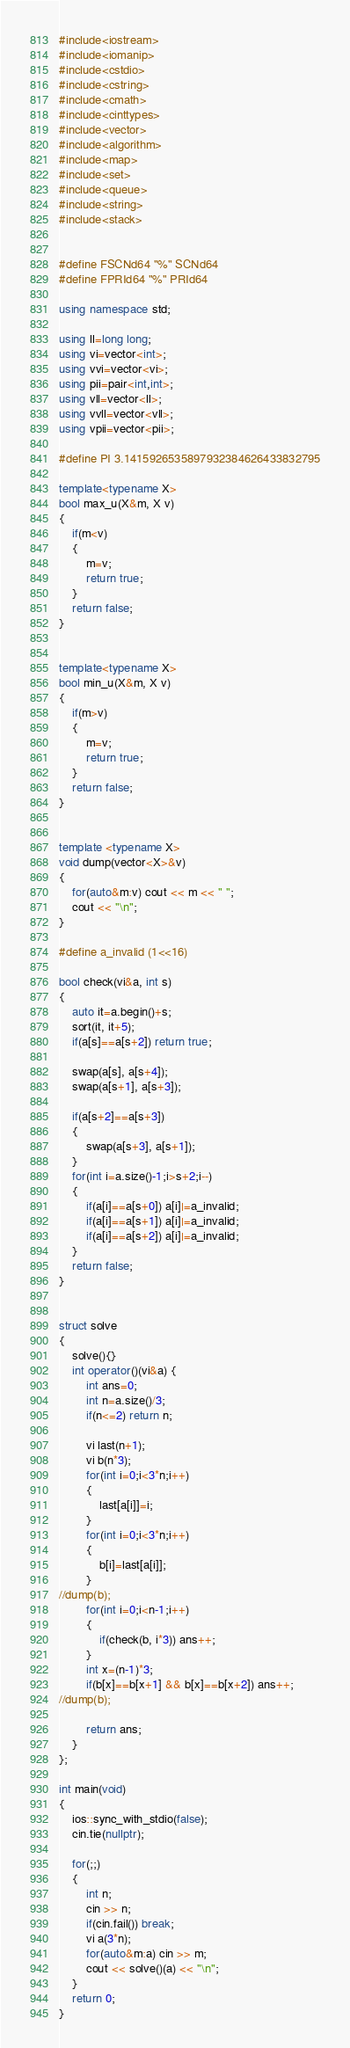<code> <loc_0><loc_0><loc_500><loc_500><_C++_>#include<iostream>
#include<iomanip>
#include<cstdio>
#include<cstring>
#include<cmath>
#include<cinttypes>
#include<vector>
#include<algorithm>
#include<map>
#include<set>
#include<queue>
#include<string>
#include<stack>


#define FSCNd64 "%" SCNd64
#define FPRId64 "%" PRId64

using namespace std;

using ll=long long;
using vi=vector<int>;
using vvi=vector<vi>;
using pii=pair<int,int>;
using vll=vector<ll>;
using vvll=vector<vll>;
using vpii=vector<pii>;

#define PI 3.1415926535897932384626433832795

template<typename X>
bool max_u(X&m, X v)
{
	if(m<v)
	{
		m=v;
		return true;
	}
	return false;
}


template<typename X>
bool min_u(X&m, X v)
{
	if(m>v)
	{
		m=v;
		return true;
	}
	return false;
}


template <typename X>
void dump(vector<X>&v)
{
	for(auto&m:v) cout << m << " ";
	cout << "\n";
}

#define a_invalid (1<<16)

bool check(vi&a, int s)
{
	auto it=a.begin()+s;
	sort(it, it+5);
	if(a[s]==a[s+2]) return true;

	swap(a[s], a[s+4]);
	swap(a[s+1], a[s+3]);

	if(a[s+2]==a[s+3])
	{
		swap(a[s+3], a[s+1]);
	}
	for(int i=a.size()-1;i>s+2;i--)
	{
		if(a[i]==a[s+0]) a[i]|=a_invalid;
		if(a[i]==a[s+1]) a[i]|=a_invalid;
		if(a[i]==a[s+2]) a[i]|=a_invalid;
	}
	return false;
}


struct solve
{
	solve(){}
	int operator()(vi&a) {
		int ans=0;
		int n=a.size()/3;
		if(n<=2) return n;

		vi last(n+1);
		vi b(n*3);
		for(int i=0;i<3*n;i++)
		{
			last[a[i]]=i;
		}
		for(int i=0;i<3*n;i++)
		{
			b[i]=last[a[i]];
		}
//dump(b);
		for(int i=0;i<n-1;i++)
		{
			if(check(b, i*3)) ans++;
		}
		int x=(n-1)*3;
		if(b[x]==b[x+1] && b[x]==b[x+2]) ans++;
//dump(b);

		return ans;
	}
};

int main(void)
{
	ios::sync_with_stdio(false);
	cin.tie(nullptr);

	for(;;)
	{
		int n;
		cin >> n;
		if(cin.fail()) break;
		vi a(3*n);
		for(auto&m:a) cin >> m;
		cout << solve()(a) << "\n";
	}
	return 0;
}
</code> 